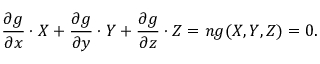<formula> <loc_0><loc_0><loc_500><loc_500>{ \frac { \partial g } { \partial x } } \cdot X + { \frac { \partial g } { \partial y } } \cdot Y + { \frac { \partial g } { \partial z } } \cdot Z = n g ( X , Y , Z ) = 0 .</formula> 